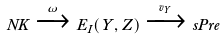<formula> <loc_0><loc_0><loc_500><loc_500>N K \xrightarrow { \omega } E _ { I } ( Y , Z ) \xrightarrow { v _ { Y } } s P r e</formula> 